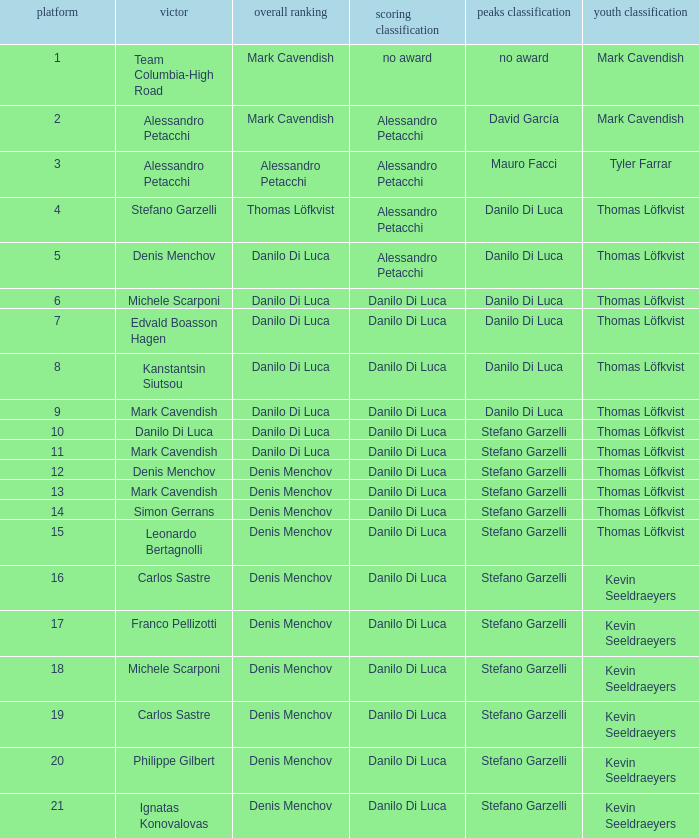When philippe gilbert is the winner who is the points classification? Danilo Di Luca. 